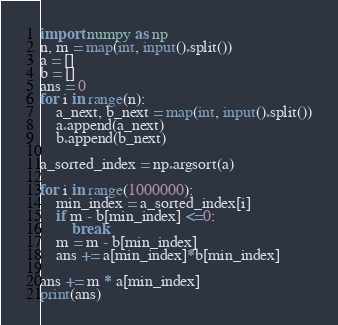<code> <loc_0><loc_0><loc_500><loc_500><_Python_>import numpy as np
n, m = map(int, input().split())
a = []
b = []
ans = 0
for i in range(n):
    a_next, b_next = map(int, input().split())
    a.append(a_next)
    b.append(b_next)

a_sorted_index = np.argsort(a)

for i in range(1000000):
    min_index = a_sorted_index[i]
    if m - b[min_index] <=0:
        break
    m = m - b[min_index]
    ans += a[min_index]*b[min_index]

ans += m * a[min_index]
print(ans)</code> 